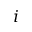Convert formula to latex. <formula><loc_0><loc_0><loc_500><loc_500>i</formula> 